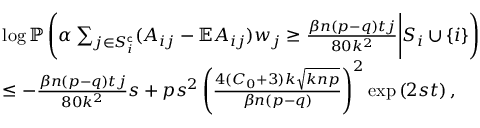<formula> <loc_0><loc_0><loc_500><loc_500>\begin{array} { r l } & { \log \mathbb { P } \left ( \alpha \sum _ { j \in S _ { i } ^ { c } } ( A _ { i j } - \mathbb { E } A _ { i j } ) w _ { j } \geq \frac { \beta n ( p - q ) t j } { 8 0 k ^ { 2 } } \Big | S _ { i } \cup \{ i \} \right ) } \\ & { \leq - \frac { \beta n ( p - q ) t j } { 8 0 k ^ { 2 } } s + p s ^ { 2 } \left ( \frac { 4 ( C _ { 0 } + 3 ) k \sqrt { k n p } } { \beta n ( p - q ) } \right ) ^ { 2 } \exp \left ( 2 { s } t \right ) , } \end{array}</formula> 